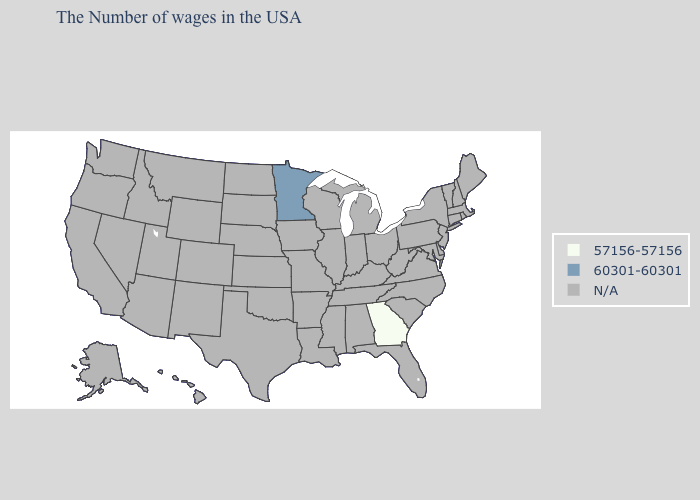Name the states that have a value in the range 60301-60301?
Answer briefly. Minnesota. Name the states that have a value in the range 60301-60301?
Be succinct. Minnesota. Which states have the lowest value in the MidWest?
Keep it brief. Minnesota. Name the states that have a value in the range 57156-57156?
Short answer required. Georgia. What is the value of Alabama?
Short answer required. N/A. Does the first symbol in the legend represent the smallest category?
Give a very brief answer. Yes. What is the value of Rhode Island?
Concise answer only. N/A. What is the value of Texas?
Keep it brief. N/A. Name the states that have a value in the range 60301-60301?
Concise answer only. Minnesota. Name the states that have a value in the range N/A?
Keep it brief. Maine, Massachusetts, Rhode Island, New Hampshire, Vermont, Connecticut, New York, New Jersey, Delaware, Maryland, Pennsylvania, Virginia, North Carolina, South Carolina, West Virginia, Ohio, Florida, Michigan, Kentucky, Indiana, Alabama, Tennessee, Wisconsin, Illinois, Mississippi, Louisiana, Missouri, Arkansas, Iowa, Kansas, Nebraska, Oklahoma, Texas, South Dakota, North Dakota, Wyoming, Colorado, New Mexico, Utah, Montana, Arizona, Idaho, Nevada, California, Washington, Oregon, Alaska, Hawaii. 